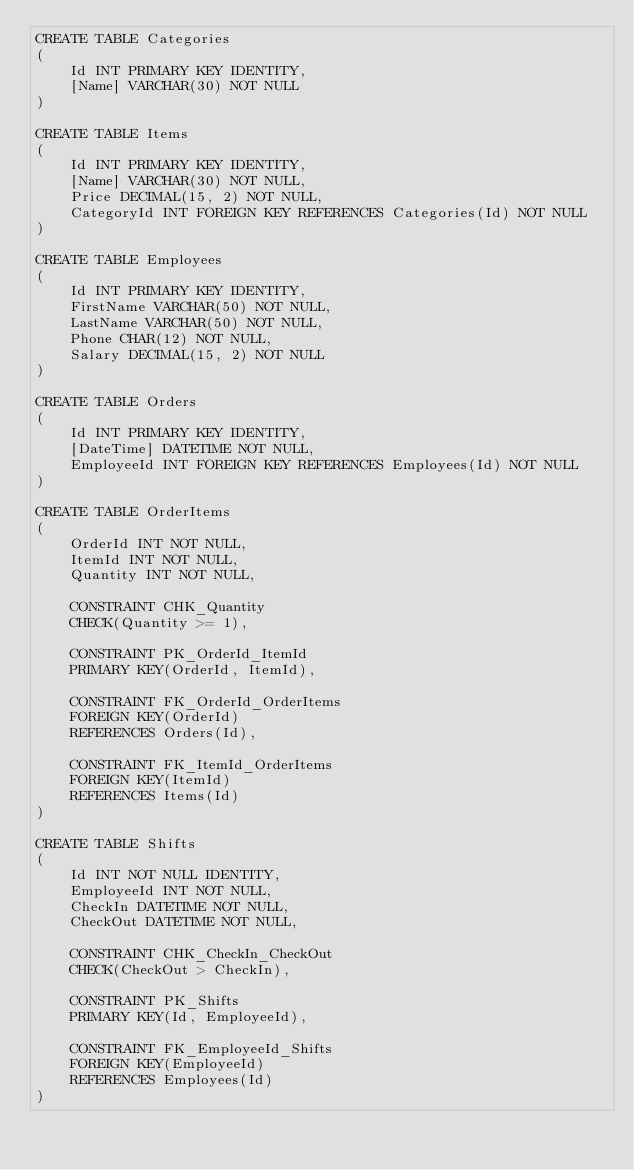Convert code to text. <code><loc_0><loc_0><loc_500><loc_500><_SQL_>CREATE TABLE Categories
(
	Id INT PRIMARY KEY IDENTITY,
	[Name] VARCHAR(30) NOT NULL
)

CREATE TABLE Items
(
	Id INT PRIMARY KEY IDENTITY,
	[Name] VARCHAR(30) NOT NULL,
	Price DECIMAL(15, 2) NOT NULL,
	CategoryId INT FOREIGN KEY REFERENCES Categories(Id) NOT NULL
)

CREATE TABLE Employees
(
	Id INT PRIMARY KEY IDENTITY,
	FirstName VARCHAR(50) NOT NULL,
	LastName VARCHAR(50) NOT NULL,
	Phone CHAR(12) NOT NULL,
	Salary DECIMAL(15, 2) NOT NULL
)

CREATE TABLE Orders
(
	Id INT PRIMARY KEY IDENTITY,
	[DateTime] DATETIME NOT NULL,
	EmployeeId INT FOREIGN KEY REFERENCES Employees(Id) NOT NULL
)

CREATE TABLE OrderItems
(
	OrderId INT NOT NULL,
	ItemId INT NOT NULL,
	Quantity INT NOT NULL,

	CONSTRAINT CHK_Quantity
	CHECK(Quantity >= 1),

	CONSTRAINT PK_OrderId_ItemId
	PRIMARY KEY(OrderId, ItemId),
	
	CONSTRAINT FK_OrderId_OrderItems
	FOREIGN KEY(OrderId)
	REFERENCES Orders(Id),

	CONSTRAINT FK_ItemId_OrderItems
	FOREIGN KEY(ItemId)
	REFERENCES Items(Id)
)

CREATE TABLE Shifts
(
	Id INT NOT NULL IDENTITY,
	EmployeeId INT NOT NULL,
	CheckIn DATETIME NOT NULL,
	CheckOut DATETIME NOT NULL,

	CONSTRAINT CHK_CheckIn_CheckOut
	CHECK(CheckOut > CheckIn),

	CONSTRAINT PK_Shifts
	PRIMARY KEY(Id, EmployeeId),

	CONSTRAINT FK_EmployeeId_Shifts
	FOREIGN KEY(EmployeeId)
	REFERENCES Employees(Id)
)</code> 